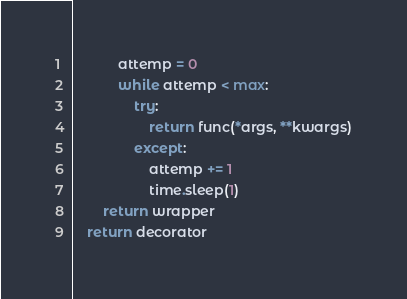Convert code to text. <code><loc_0><loc_0><loc_500><loc_500><_Python_>            attemp = 0
            while attemp < max:
                try:
                    return func(*args, **kwargs)
                except:
                    attemp += 1
                    time.sleep(1)
        return wrapper
    return decorator
</code> 